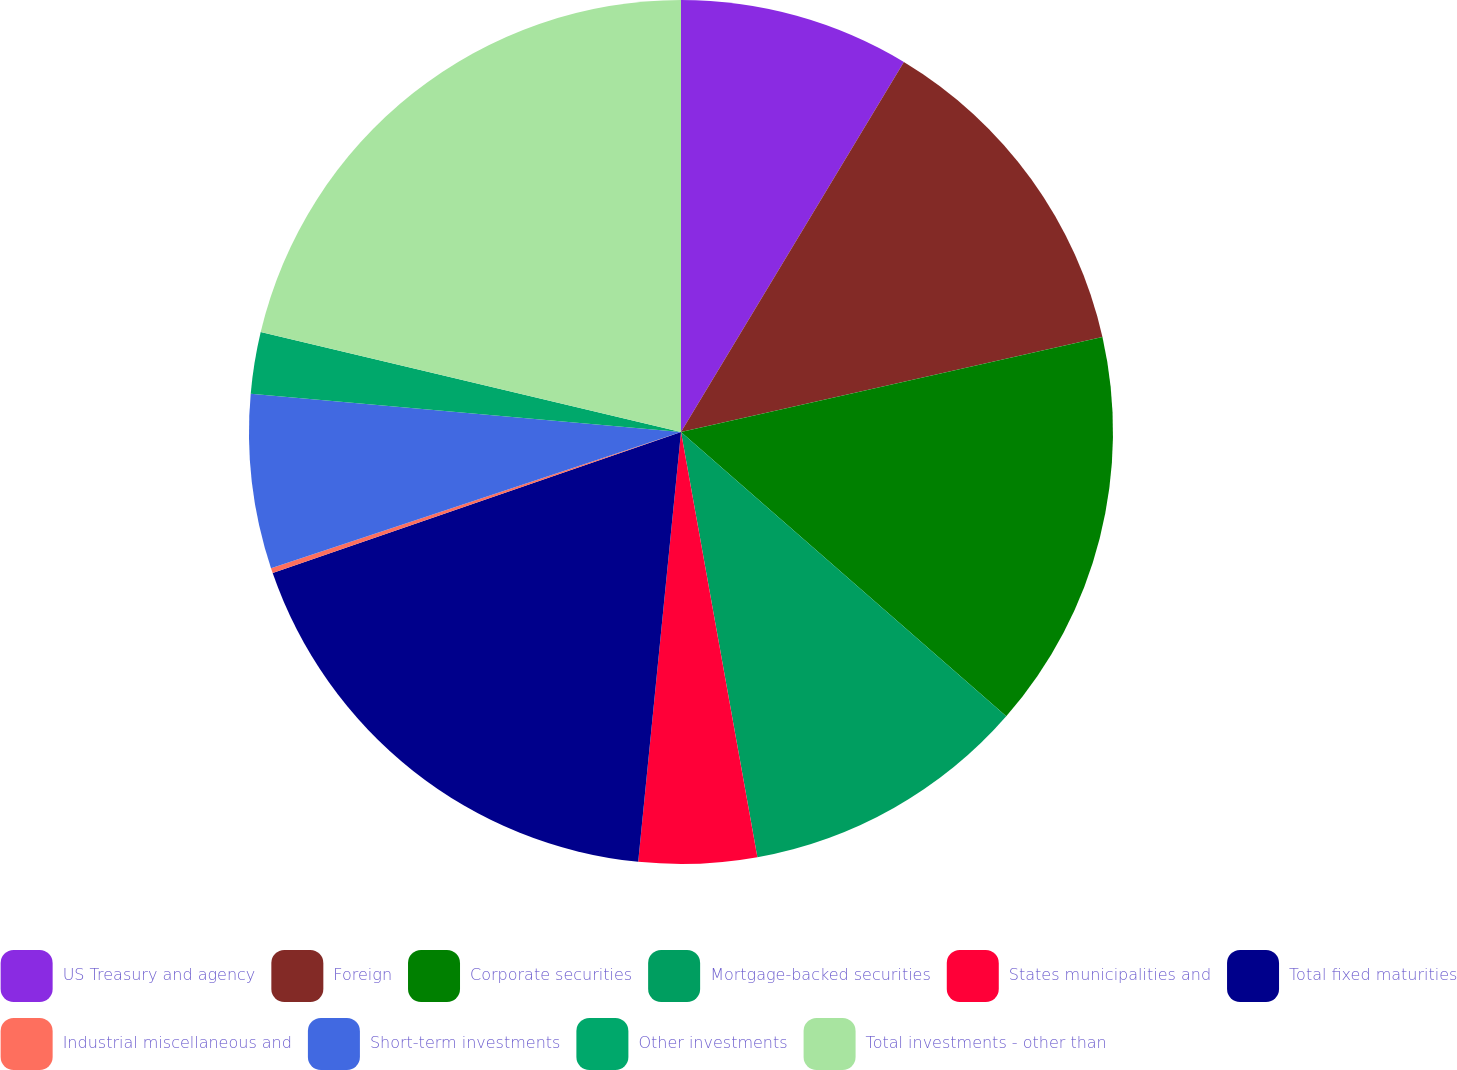Convert chart. <chart><loc_0><loc_0><loc_500><loc_500><pie_chart><fcel>US Treasury and agency<fcel>Foreign<fcel>Corporate securities<fcel>Mortgage-backed securities<fcel>States municipalities and<fcel>Total fixed maturities<fcel>Industrial miscellaneous and<fcel>Short-term investments<fcel>Other investments<fcel>Total investments - other than<nl><fcel>8.63%<fcel>12.85%<fcel>14.96%<fcel>10.74%<fcel>4.41%<fcel>18.13%<fcel>0.19%<fcel>6.52%<fcel>2.3%<fcel>21.29%<nl></chart> 